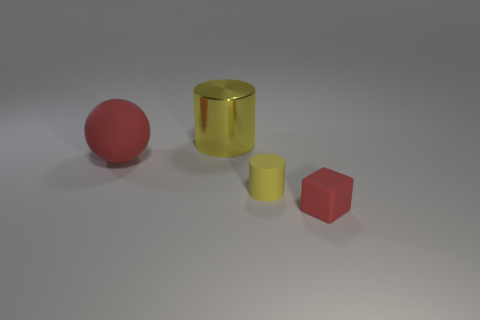How many other things are the same color as the tiny matte cylinder?
Offer a terse response. 1. Do the tiny cube and the cylinder in front of the red sphere have the same material?
Ensure brevity in your answer.  Yes. What number of red matte things are to the left of the tiny cylinder that is on the left side of the red rubber thing on the right side of the rubber ball?
Your answer should be very brief. 1. Are there fewer red rubber things that are to the right of the tiny red matte cube than yellow matte objects that are behind the tiny yellow thing?
Keep it short and to the point. No. How many other things are the same material as the ball?
Your response must be concise. 2. There is a object that is the same size as the red matte sphere; what is it made of?
Give a very brief answer. Metal. What number of blue things are small shiny spheres or rubber balls?
Provide a succinct answer. 0. What is the color of the thing that is both on the left side of the small red rubber thing and right of the large yellow cylinder?
Keep it short and to the point. Yellow. Is the red object that is in front of the large red thing made of the same material as the red object left of the cube?
Offer a terse response. Yes. Are there more small yellow objects that are right of the tiny red thing than big red spheres that are in front of the yellow rubber cylinder?
Your response must be concise. No. 